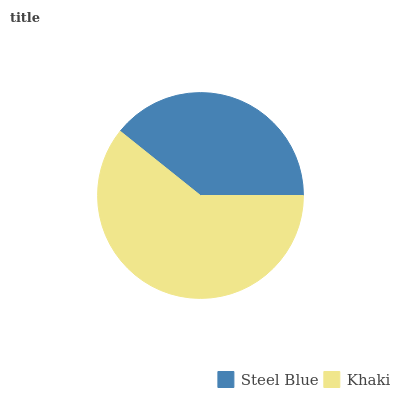Is Steel Blue the minimum?
Answer yes or no. Yes. Is Khaki the maximum?
Answer yes or no. Yes. Is Khaki the minimum?
Answer yes or no. No. Is Khaki greater than Steel Blue?
Answer yes or no. Yes. Is Steel Blue less than Khaki?
Answer yes or no. Yes. Is Steel Blue greater than Khaki?
Answer yes or no. No. Is Khaki less than Steel Blue?
Answer yes or no. No. Is Khaki the high median?
Answer yes or no. Yes. Is Steel Blue the low median?
Answer yes or no. Yes. Is Steel Blue the high median?
Answer yes or no. No. Is Khaki the low median?
Answer yes or no. No. 